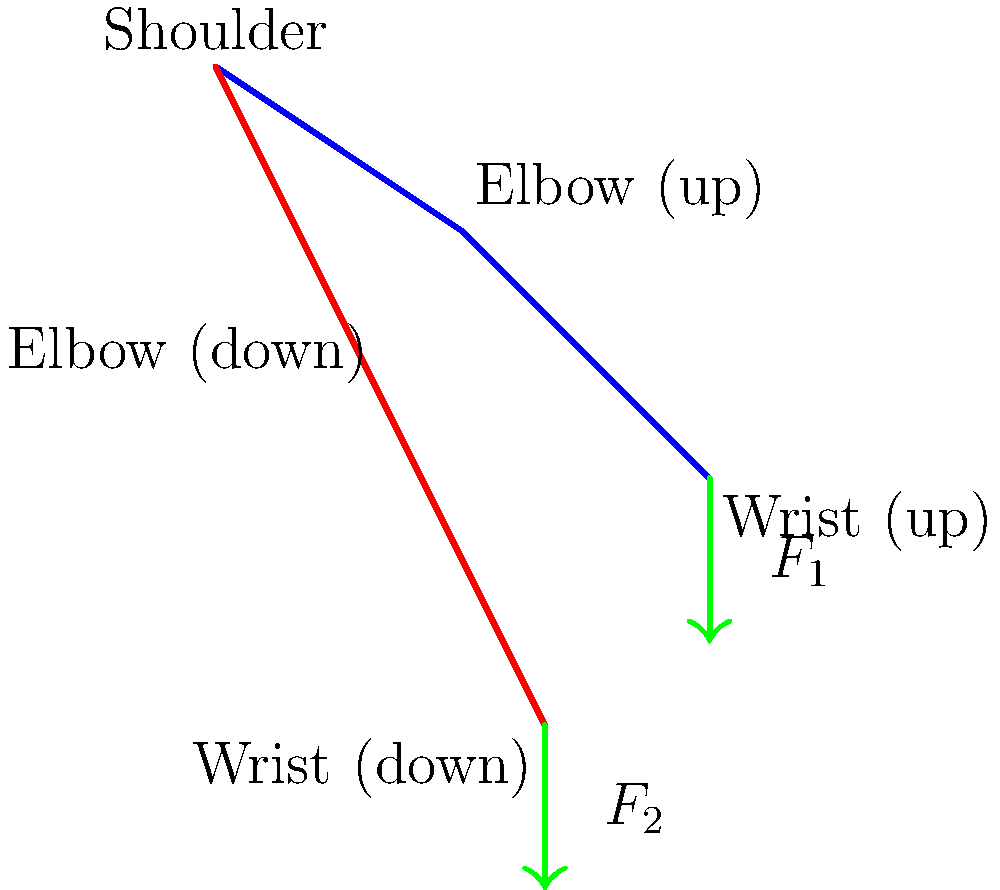As a drummer, you're analyzing the forces involved in a typical drumming motion. The diagram shows two arm positions: up (blue) and down (red). If the force exerted on the drumstick at the lower position ($F_2$) is 1.5 times the force at the upper position ($F_1$), and the total work done in moving from the upper to the lower position is 40 J, calculate the magnitude of $F_1$ given that the vertical displacement of the wrist is 0.3 m. Let's approach this step-by-step:

1) We know that $F_2 = 1.5F_1$

2) The work done is equal to the average force multiplied by the displacement:
   $W = F_{avg} \cdot d$

3) The average force is the mean of $F_1$ and $F_2$:
   $F_{avg} = \frac{F_1 + F_2}{2} = \frac{F_1 + 1.5F_1}{2} = 1.25F_1$

4) Substituting into the work equation:
   $40 = 1.25F_1 \cdot 0.3$

5) Solve for $F_1$:
   $F_1 = \frac{40}{1.25 \cdot 0.3} = \frac{40}{0.375} = 106.67$ N

6) Round to a reasonable precision:
   $F_1 \approx 107$ N
Answer: 107 N 